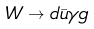<formula> <loc_0><loc_0><loc_500><loc_500>W \rightarrow d \bar { u } \gamma g</formula> 